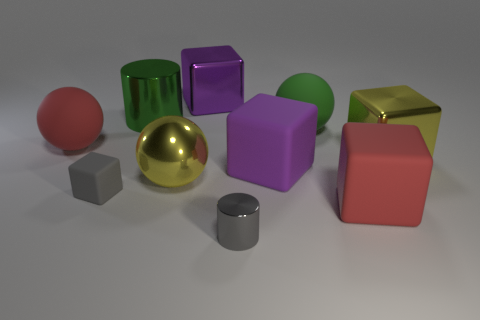Subtract 1 cubes. How many cubes are left? 4 Subtract all red blocks. How many blocks are left? 4 Subtract all big purple metallic blocks. How many blocks are left? 4 Subtract all blue blocks. Subtract all blue balls. How many blocks are left? 5 Subtract all cylinders. How many objects are left? 8 Subtract all large red matte balls. Subtract all small cylinders. How many objects are left? 8 Add 5 rubber things. How many rubber things are left? 10 Add 3 gray shiny cubes. How many gray shiny cubes exist? 3 Subtract 0 purple spheres. How many objects are left? 10 